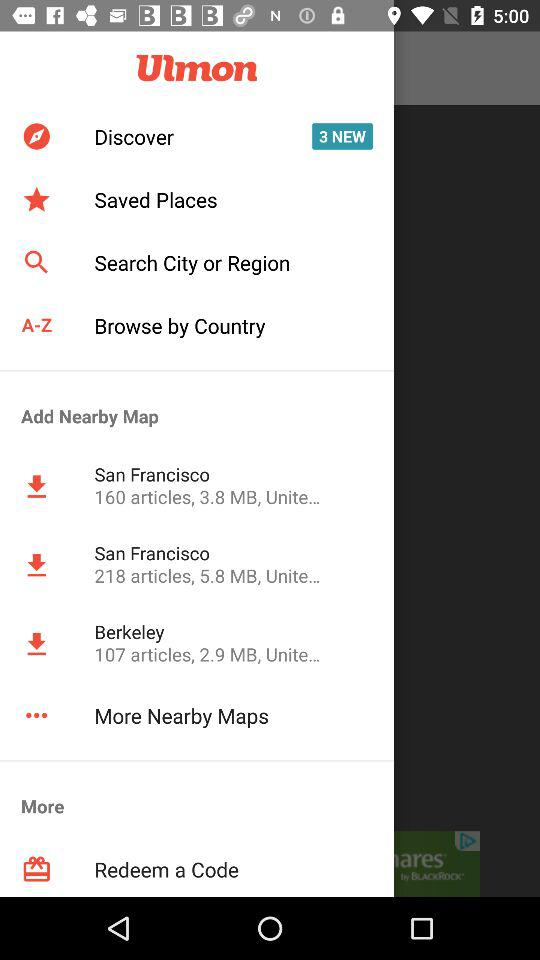How many more articles does the San Francisco map have than the Berkeley map?
Answer the question using a single word or phrase. 111 